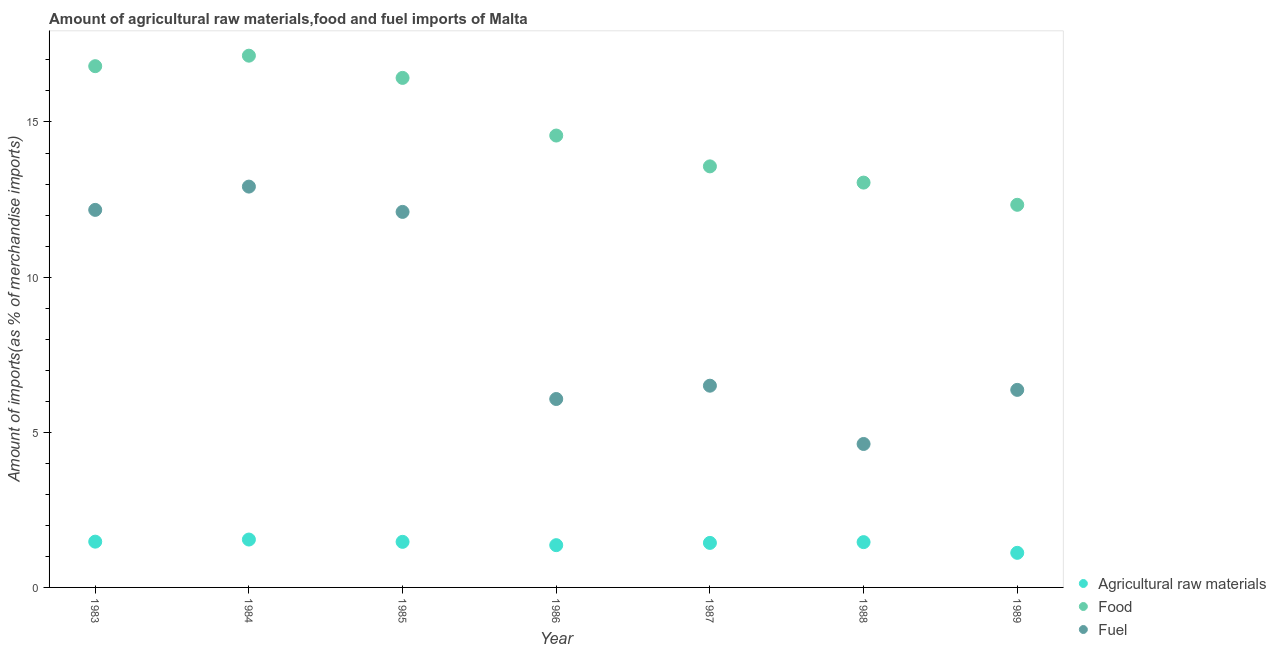How many different coloured dotlines are there?
Give a very brief answer. 3. Is the number of dotlines equal to the number of legend labels?
Provide a succinct answer. Yes. What is the percentage of food imports in 1984?
Your response must be concise. 17.14. Across all years, what is the maximum percentage of food imports?
Ensure brevity in your answer.  17.14. Across all years, what is the minimum percentage of fuel imports?
Your response must be concise. 4.62. In which year was the percentage of food imports maximum?
Keep it short and to the point. 1984. What is the total percentage of fuel imports in the graph?
Your response must be concise. 60.75. What is the difference between the percentage of fuel imports in 1986 and that in 1987?
Your answer should be very brief. -0.43. What is the difference between the percentage of raw materials imports in 1989 and the percentage of fuel imports in 1988?
Offer a terse response. -3.51. What is the average percentage of fuel imports per year?
Provide a succinct answer. 8.68. In the year 1983, what is the difference between the percentage of raw materials imports and percentage of fuel imports?
Make the answer very short. -10.69. In how many years, is the percentage of food imports greater than 15 %?
Provide a succinct answer. 3. What is the ratio of the percentage of food imports in 1985 to that in 1988?
Your response must be concise. 1.26. Is the percentage of food imports in 1984 less than that in 1988?
Provide a succinct answer. No. Is the difference between the percentage of food imports in 1986 and 1987 greater than the difference between the percentage of raw materials imports in 1986 and 1987?
Keep it short and to the point. Yes. What is the difference between the highest and the second highest percentage of raw materials imports?
Ensure brevity in your answer.  0.07. What is the difference between the highest and the lowest percentage of fuel imports?
Offer a very short reply. 8.29. In how many years, is the percentage of fuel imports greater than the average percentage of fuel imports taken over all years?
Your response must be concise. 3. Is it the case that in every year, the sum of the percentage of raw materials imports and percentage of food imports is greater than the percentage of fuel imports?
Offer a very short reply. Yes. Is the percentage of fuel imports strictly greater than the percentage of raw materials imports over the years?
Your response must be concise. Yes. How many years are there in the graph?
Keep it short and to the point. 7. What is the difference between two consecutive major ticks on the Y-axis?
Give a very brief answer. 5. Are the values on the major ticks of Y-axis written in scientific E-notation?
Give a very brief answer. No. Does the graph contain grids?
Your answer should be compact. No. Where does the legend appear in the graph?
Keep it short and to the point. Bottom right. How many legend labels are there?
Your answer should be very brief. 3. How are the legend labels stacked?
Make the answer very short. Vertical. What is the title of the graph?
Provide a short and direct response. Amount of agricultural raw materials,food and fuel imports of Malta. What is the label or title of the X-axis?
Your answer should be compact. Year. What is the label or title of the Y-axis?
Your response must be concise. Amount of imports(as % of merchandise imports). What is the Amount of imports(as % of merchandise imports) of Agricultural raw materials in 1983?
Keep it short and to the point. 1.48. What is the Amount of imports(as % of merchandise imports) of Food in 1983?
Your answer should be compact. 16.8. What is the Amount of imports(as % of merchandise imports) in Fuel in 1983?
Keep it short and to the point. 12.17. What is the Amount of imports(as % of merchandise imports) in Agricultural raw materials in 1984?
Offer a terse response. 1.54. What is the Amount of imports(as % of merchandise imports) of Food in 1984?
Give a very brief answer. 17.14. What is the Amount of imports(as % of merchandise imports) in Fuel in 1984?
Offer a terse response. 12.92. What is the Amount of imports(as % of merchandise imports) of Agricultural raw materials in 1985?
Provide a succinct answer. 1.47. What is the Amount of imports(as % of merchandise imports) in Food in 1985?
Make the answer very short. 16.42. What is the Amount of imports(as % of merchandise imports) of Fuel in 1985?
Your answer should be compact. 12.1. What is the Amount of imports(as % of merchandise imports) of Agricultural raw materials in 1986?
Ensure brevity in your answer.  1.36. What is the Amount of imports(as % of merchandise imports) in Food in 1986?
Offer a terse response. 14.56. What is the Amount of imports(as % of merchandise imports) of Fuel in 1986?
Your answer should be very brief. 6.07. What is the Amount of imports(as % of merchandise imports) of Agricultural raw materials in 1987?
Give a very brief answer. 1.43. What is the Amount of imports(as % of merchandise imports) of Food in 1987?
Offer a terse response. 13.57. What is the Amount of imports(as % of merchandise imports) of Fuel in 1987?
Make the answer very short. 6.5. What is the Amount of imports(as % of merchandise imports) in Agricultural raw materials in 1988?
Offer a very short reply. 1.46. What is the Amount of imports(as % of merchandise imports) in Food in 1988?
Make the answer very short. 13.05. What is the Amount of imports(as % of merchandise imports) of Fuel in 1988?
Provide a succinct answer. 4.62. What is the Amount of imports(as % of merchandise imports) of Agricultural raw materials in 1989?
Offer a terse response. 1.11. What is the Amount of imports(as % of merchandise imports) of Food in 1989?
Make the answer very short. 12.33. What is the Amount of imports(as % of merchandise imports) of Fuel in 1989?
Provide a succinct answer. 6.37. Across all years, what is the maximum Amount of imports(as % of merchandise imports) of Agricultural raw materials?
Make the answer very short. 1.54. Across all years, what is the maximum Amount of imports(as % of merchandise imports) of Food?
Provide a short and direct response. 17.14. Across all years, what is the maximum Amount of imports(as % of merchandise imports) in Fuel?
Make the answer very short. 12.92. Across all years, what is the minimum Amount of imports(as % of merchandise imports) in Agricultural raw materials?
Ensure brevity in your answer.  1.11. Across all years, what is the minimum Amount of imports(as % of merchandise imports) of Food?
Provide a succinct answer. 12.33. Across all years, what is the minimum Amount of imports(as % of merchandise imports) in Fuel?
Provide a succinct answer. 4.62. What is the total Amount of imports(as % of merchandise imports) in Agricultural raw materials in the graph?
Your answer should be very brief. 9.86. What is the total Amount of imports(as % of merchandise imports) in Food in the graph?
Your answer should be compact. 103.87. What is the total Amount of imports(as % of merchandise imports) in Fuel in the graph?
Provide a short and direct response. 60.75. What is the difference between the Amount of imports(as % of merchandise imports) in Agricultural raw materials in 1983 and that in 1984?
Your response must be concise. -0.07. What is the difference between the Amount of imports(as % of merchandise imports) in Food in 1983 and that in 1984?
Provide a succinct answer. -0.34. What is the difference between the Amount of imports(as % of merchandise imports) of Fuel in 1983 and that in 1984?
Give a very brief answer. -0.75. What is the difference between the Amount of imports(as % of merchandise imports) of Agricultural raw materials in 1983 and that in 1985?
Your answer should be compact. 0.01. What is the difference between the Amount of imports(as % of merchandise imports) of Food in 1983 and that in 1985?
Your answer should be very brief. 0.38. What is the difference between the Amount of imports(as % of merchandise imports) in Fuel in 1983 and that in 1985?
Give a very brief answer. 0.07. What is the difference between the Amount of imports(as % of merchandise imports) in Agricultural raw materials in 1983 and that in 1986?
Provide a short and direct response. 0.11. What is the difference between the Amount of imports(as % of merchandise imports) in Food in 1983 and that in 1986?
Your answer should be very brief. 2.24. What is the difference between the Amount of imports(as % of merchandise imports) of Fuel in 1983 and that in 1986?
Ensure brevity in your answer.  6.1. What is the difference between the Amount of imports(as % of merchandise imports) in Agricultural raw materials in 1983 and that in 1987?
Your answer should be compact. 0.04. What is the difference between the Amount of imports(as % of merchandise imports) in Food in 1983 and that in 1987?
Offer a very short reply. 3.23. What is the difference between the Amount of imports(as % of merchandise imports) of Fuel in 1983 and that in 1987?
Your answer should be compact. 5.67. What is the difference between the Amount of imports(as % of merchandise imports) in Agricultural raw materials in 1983 and that in 1988?
Provide a short and direct response. 0.02. What is the difference between the Amount of imports(as % of merchandise imports) of Food in 1983 and that in 1988?
Your response must be concise. 3.75. What is the difference between the Amount of imports(as % of merchandise imports) in Fuel in 1983 and that in 1988?
Ensure brevity in your answer.  7.54. What is the difference between the Amount of imports(as % of merchandise imports) in Agricultural raw materials in 1983 and that in 1989?
Offer a terse response. 0.36. What is the difference between the Amount of imports(as % of merchandise imports) in Food in 1983 and that in 1989?
Offer a terse response. 4.47. What is the difference between the Amount of imports(as % of merchandise imports) of Fuel in 1983 and that in 1989?
Ensure brevity in your answer.  5.8. What is the difference between the Amount of imports(as % of merchandise imports) in Agricultural raw materials in 1984 and that in 1985?
Your response must be concise. 0.07. What is the difference between the Amount of imports(as % of merchandise imports) of Food in 1984 and that in 1985?
Keep it short and to the point. 0.72. What is the difference between the Amount of imports(as % of merchandise imports) in Fuel in 1984 and that in 1985?
Provide a succinct answer. 0.82. What is the difference between the Amount of imports(as % of merchandise imports) of Agricultural raw materials in 1984 and that in 1986?
Give a very brief answer. 0.18. What is the difference between the Amount of imports(as % of merchandise imports) in Food in 1984 and that in 1986?
Keep it short and to the point. 2.57. What is the difference between the Amount of imports(as % of merchandise imports) in Fuel in 1984 and that in 1986?
Offer a very short reply. 6.85. What is the difference between the Amount of imports(as % of merchandise imports) in Agricultural raw materials in 1984 and that in 1987?
Provide a short and direct response. 0.11. What is the difference between the Amount of imports(as % of merchandise imports) in Food in 1984 and that in 1987?
Offer a terse response. 3.57. What is the difference between the Amount of imports(as % of merchandise imports) in Fuel in 1984 and that in 1987?
Make the answer very short. 6.42. What is the difference between the Amount of imports(as % of merchandise imports) of Agricultural raw materials in 1984 and that in 1988?
Your answer should be very brief. 0.08. What is the difference between the Amount of imports(as % of merchandise imports) in Food in 1984 and that in 1988?
Ensure brevity in your answer.  4.09. What is the difference between the Amount of imports(as % of merchandise imports) of Fuel in 1984 and that in 1988?
Provide a succinct answer. 8.29. What is the difference between the Amount of imports(as % of merchandise imports) in Agricultural raw materials in 1984 and that in 1989?
Offer a terse response. 0.43. What is the difference between the Amount of imports(as % of merchandise imports) of Food in 1984 and that in 1989?
Make the answer very short. 4.81. What is the difference between the Amount of imports(as % of merchandise imports) in Fuel in 1984 and that in 1989?
Your response must be concise. 6.55. What is the difference between the Amount of imports(as % of merchandise imports) in Agricultural raw materials in 1985 and that in 1986?
Make the answer very short. 0.11. What is the difference between the Amount of imports(as % of merchandise imports) in Food in 1985 and that in 1986?
Provide a succinct answer. 1.86. What is the difference between the Amount of imports(as % of merchandise imports) in Fuel in 1985 and that in 1986?
Make the answer very short. 6.03. What is the difference between the Amount of imports(as % of merchandise imports) in Agricultural raw materials in 1985 and that in 1987?
Offer a very short reply. 0.03. What is the difference between the Amount of imports(as % of merchandise imports) in Food in 1985 and that in 1987?
Your answer should be compact. 2.85. What is the difference between the Amount of imports(as % of merchandise imports) in Fuel in 1985 and that in 1987?
Offer a terse response. 5.6. What is the difference between the Amount of imports(as % of merchandise imports) in Agricultural raw materials in 1985 and that in 1988?
Offer a terse response. 0.01. What is the difference between the Amount of imports(as % of merchandise imports) in Food in 1985 and that in 1988?
Provide a succinct answer. 3.37. What is the difference between the Amount of imports(as % of merchandise imports) in Fuel in 1985 and that in 1988?
Offer a very short reply. 7.48. What is the difference between the Amount of imports(as % of merchandise imports) in Agricultural raw materials in 1985 and that in 1989?
Provide a succinct answer. 0.35. What is the difference between the Amount of imports(as % of merchandise imports) in Food in 1985 and that in 1989?
Offer a terse response. 4.09. What is the difference between the Amount of imports(as % of merchandise imports) of Fuel in 1985 and that in 1989?
Offer a very short reply. 5.74. What is the difference between the Amount of imports(as % of merchandise imports) of Agricultural raw materials in 1986 and that in 1987?
Make the answer very short. -0.07. What is the difference between the Amount of imports(as % of merchandise imports) of Fuel in 1986 and that in 1987?
Offer a very short reply. -0.43. What is the difference between the Amount of imports(as % of merchandise imports) of Agricultural raw materials in 1986 and that in 1988?
Make the answer very short. -0.1. What is the difference between the Amount of imports(as % of merchandise imports) of Food in 1986 and that in 1988?
Keep it short and to the point. 1.52. What is the difference between the Amount of imports(as % of merchandise imports) in Fuel in 1986 and that in 1988?
Your answer should be very brief. 1.45. What is the difference between the Amount of imports(as % of merchandise imports) in Agricultural raw materials in 1986 and that in 1989?
Provide a short and direct response. 0.25. What is the difference between the Amount of imports(as % of merchandise imports) of Food in 1986 and that in 1989?
Offer a terse response. 2.23. What is the difference between the Amount of imports(as % of merchandise imports) of Fuel in 1986 and that in 1989?
Make the answer very short. -0.29. What is the difference between the Amount of imports(as % of merchandise imports) in Agricultural raw materials in 1987 and that in 1988?
Make the answer very short. -0.02. What is the difference between the Amount of imports(as % of merchandise imports) in Food in 1987 and that in 1988?
Give a very brief answer. 0.52. What is the difference between the Amount of imports(as % of merchandise imports) of Fuel in 1987 and that in 1988?
Ensure brevity in your answer.  1.88. What is the difference between the Amount of imports(as % of merchandise imports) in Agricultural raw materials in 1987 and that in 1989?
Your answer should be compact. 0.32. What is the difference between the Amount of imports(as % of merchandise imports) of Food in 1987 and that in 1989?
Keep it short and to the point. 1.24. What is the difference between the Amount of imports(as % of merchandise imports) in Fuel in 1987 and that in 1989?
Give a very brief answer. 0.13. What is the difference between the Amount of imports(as % of merchandise imports) in Agricultural raw materials in 1988 and that in 1989?
Offer a very short reply. 0.34. What is the difference between the Amount of imports(as % of merchandise imports) of Food in 1988 and that in 1989?
Your answer should be very brief. 0.72. What is the difference between the Amount of imports(as % of merchandise imports) of Fuel in 1988 and that in 1989?
Offer a very short reply. -1.74. What is the difference between the Amount of imports(as % of merchandise imports) in Agricultural raw materials in 1983 and the Amount of imports(as % of merchandise imports) in Food in 1984?
Offer a very short reply. -15.66. What is the difference between the Amount of imports(as % of merchandise imports) of Agricultural raw materials in 1983 and the Amount of imports(as % of merchandise imports) of Fuel in 1984?
Make the answer very short. -11.44. What is the difference between the Amount of imports(as % of merchandise imports) of Food in 1983 and the Amount of imports(as % of merchandise imports) of Fuel in 1984?
Give a very brief answer. 3.88. What is the difference between the Amount of imports(as % of merchandise imports) of Agricultural raw materials in 1983 and the Amount of imports(as % of merchandise imports) of Food in 1985?
Make the answer very short. -14.95. What is the difference between the Amount of imports(as % of merchandise imports) of Agricultural raw materials in 1983 and the Amount of imports(as % of merchandise imports) of Fuel in 1985?
Offer a terse response. -10.63. What is the difference between the Amount of imports(as % of merchandise imports) of Food in 1983 and the Amount of imports(as % of merchandise imports) of Fuel in 1985?
Your response must be concise. 4.7. What is the difference between the Amount of imports(as % of merchandise imports) in Agricultural raw materials in 1983 and the Amount of imports(as % of merchandise imports) in Food in 1986?
Your answer should be very brief. -13.09. What is the difference between the Amount of imports(as % of merchandise imports) of Agricultural raw materials in 1983 and the Amount of imports(as % of merchandise imports) of Fuel in 1986?
Offer a terse response. -4.6. What is the difference between the Amount of imports(as % of merchandise imports) of Food in 1983 and the Amount of imports(as % of merchandise imports) of Fuel in 1986?
Provide a succinct answer. 10.73. What is the difference between the Amount of imports(as % of merchandise imports) of Agricultural raw materials in 1983 and the Amount of imports(as % of merchandise imports) of Food in 1987?
Your answer should be compact. -12.09. What is the difference between the Amount of imports(as % of merchandise imports) in Agricultural raw materials in 1983 and the Amount of imports(as % of merchandise imports) in Fuel in 1987?
Make the answer very short. -5.03. What is the difference between the Amount of imports(as % of merchandise imports) in Food in 1983 and the Amount of imports(as % of merchandise imports) in Fuel in 1987?
Make the answer very short. 10.3. What is the difference between the Amount of imports(as % of merchandise imports) of Agricultural raw materials in 1983 and the Amount of imports(as % of merchandise imports) of Food in 1988?
Make the answer very short. -11.57. What is the difference between the Amount of imports(as % of merchandise imports) in Agricultural raw materials in 1983 and the Amount of imports(as % of merchandise imports) in Fuel in 1988?
Offer a terse response. -3.15. What is the difference between the Amount of imports(as % of merchandise imports) in Food in 1983 and the Amount of imports(as % of merchandise imports) in Fuel in 1988?
Keep it short and to the point. 12.18. What is the difference between the Amount of imports(as % of merchandise imports) of Agricultural raw materials in 1983 and the Amount of imports(as % of merchandise imports) of Food in 1989?
Provide a short and direct response. -10.86. What is the difference between the Amount of imports(as % of merchandise imports) in Agricultural raw materials in 1983 and the Amount of imports(as % of merchandise imports) in Fuel in 1989?
Offer a terse response. -4.89. What is the difference between the Amount of imports(as % of merchandise imports) of Food in 1983 and the Amount of imports(as % of merchandise imports) of Fuel in 1989?
Provide a succinct answer. 10.43. What is the difference between the Amount of imports(as % of merchandise imports) in Agricultural raw materials in 1984 and the Amount of imports(as % of merchandise imports) in Food in 1985?
Provide a succinct answer. -14.88. What is the difference between the Amount of imports(as % of merchandise imports) in Agricultural raw materials in 1984 and the Amount of imports(as % of merchandise imports) in Fuel in 1985?
Your answer should be compact. -10.56. What is the difference between the Amount of imports(as % of merchandise imports) in Food in 1984 and the Amount of imports(as % of merchandise imports) in Fuel in 1985?
Keep it short and to the point. 5.03. What is the difference between the Amount of imports(as % of merchandise imports) of Agricultural raw materials in 1984 and the Amount of imports(as % of merchandise imports) of Food in 1986?
Offer a very short reply. -13.02. What is the difference between the Amount of imports(as % of merchandise imports) of Agricultural raw materials in 1984 and the Amount of imports(as % of merchandise imports) of Fuel in 1986?
Make the answer very short. -4.53. What is the difference between the Amount of imports(as % of merchandise imports) in Food in 1984 and the Amount of imports(as % of merchandise imports) in Fuel in 1986?
Your answer should be compact. 11.06. What is the difference between the Amount of imports(as % of merchandise imports) of Agricultural raw materials in 1984 and the Amount of imports(as % of merchandise imports) of Food in 1987?
Give a very brief answer. -12.03. What is the difference between the Amount of imports(as % of merchandise imports) in Agricultural raw materials in 1984 and the Amount of imports(as % of merchandise imports) in Fuel in 1987?
Keep it short and to the point. -4.96. What is the difference between the Amount of imports(as % of merchandise imports) in Food in 1984 and the Amount of imports(as % of merchandise imports) in Fuel in 1987?
Provide a succinct answer. 10.64. What is the difference between the Amount of imports(as % of merchandise imports) of Agricultural raw materials in 1984 and the Amount of imports(as % of merchandise imports) of Food in 1988?
Your response must be concise. -11.5. What is the difference between the Amount of imports(as % of merchandise imports) of Agricultural raw materials in 1984 and the Amount of imports(as % of merchandise imports) of Fuel in 1988?
Your answer should be very brief. -3.08. What is the difference between the Amount of imports(as % of merchandise imports) of Food in 1984 and the Amount of imports(as % of merchandise imports) of Fuel in 1988?
Provide a short and direct response. 12.51. What is the difference between the Amount of imports(as % of merchandise imports) in Agricultural raw materials in 1984 and the Amount of imports(as % of merchandise imports) in Food in 1989?
Keep it short and to the point. -10.79. What is the difference between the Amount of imports(as % of merchandise imports) in Agricultural raw materials in 1984 and the Amount of imports(as % of merchandise imports) in Fuel in 1989?
Offer a very short reply. -4.82. What is the difference between the Amount of imports(as % of merchandise imports) in Food in 1984 and the Amount of imports(as % of merchandise imports) in Fuel in 1989?
Provide a succinct answer. 10.77. What is the difference between the Amount of imports(as % of merchandise imports) in Agricultural raw materials in 1985 and the Amount of imports(as % of merchandise imports) in Food in 1986?
Your response must be concise. -13.09. What is the difference between the Amount of imports(as % of merchandise imports) of Agricultural raw materials in 1985 and the Amount of imports(as % of merchandise imports) of Fuel in 1986?
Make the answer very short. -4.6. What is the difference between the Amount of imports(as % of merchandise imports) of Food in 1985 and the Amount of imports(as % of merchandise imports) of Fuel in 1986?
Your answer should be compact. 10.35. What is the difference between the Amount of imports(as % of merchandise imports) in Agricultural raw materials in 1985 and the Amount of imports(as % of merchandise imports) in Food in 1987?
Your answer should be compact. -12.1. What is the difference between the Amount of imports(as % of merchandise imports) of Agricultural raw materials in 1985 and the Amount of imports(as % of merchandise imports) of Fuel in 1987?
Offer a terse response. -5.03. What is the difference between the Amount of imports(as % of merchandise imports) of Food in 1985 and the Amount of imports(as % of merchandise imports) of Fuel in 1987?
Ensure brevity in your answer.  9.92. What is the difference between the Amount of imports(as % of merchandise imports) in Agricultural raw materials in 1985 and the Amount of imports(as % of merchandise imports) in Food in 1988?
Your answer should be very brief. -11.58. What is the difference between the Amount of imports(as % of merchandise imports) of Agricultural raw materials in 1985 and the Amount of imports(as % of merchandise imports) of Fuel in 1988?
Provide a succinct answer. -3.15. What is the difference between the Amount of imports(as % of merchandise imports) of Food in 1985 and the Amount of imports(as % of merchandise imports) of Fuel in 1988?
Give a very brief answer. 11.8. What is the difference between the Amount of imports(as % of merchandise imports) of Agricultural raw materials in 1985 and the Amount of imports(as % of merchandise imports) of Food in 1989?
Offer a very short reply. -10.86. What is the difference between the Amount of imports(as % of merchandise imports) in Agricultural raw materials in 1985 and the Amount of imports(as % of merchandise imports) in Fuel in 1989?
Keep it short and to the point. -4.9. What is the difference between the Amount of imports(as % of merchandise imports) of Food in 1985 and the Amount of imports(as % of merchandise imports) of Fuel in 1989?
Provide a succinct answer. 10.05. What is the difference between the Amount of imports(as % of merchandise imports) of Agricultural raw materials in 1986 and the Amount of imports(as % of merchandise imports) of Food in 1987?
Make the answer very short. -12.21. What is the difference between the Amount of imports(as % of merchandise imports) of Agricultural raw materials in 1986 and the Amount of imports(as % of merchandise imports) of Fuel in 1987?
Keep it short and to the point. -5.14. What is the difference between the Amount of imports(as % of merchandise imports) of Food in 1986 and the Amount of imports(as % of merchandise imports) of Fuel in 1987?
Provide a succinct answer. 8.06. What is the difference between the Amount of imports(as % of merchandise imports) of Agricultural raw materials in 1986 and the Amount of imports(as % of merchandise imports) of Food in 1988?
Your answer should be very brief. -11.68. What is the difference between the Amount of imports(as % of merchandise imports) in Agricultural raw materials in 1986 and the Amount of imports(as % of merchandise imports) in Fuel in 1988?
Provide a succinct answer. -3.26. What is the difference between the Amount of imports(as % of merchandise imports) of Food in 1986 and the Amount of imports(as % of merchandise imports) of Fuel in 1988?
Give a very brief answer. 9.94. What is the difference between the Amount of imports(as % of merchandise imports) of Agricultural raw materials in 1986 and the Amount of imports(as % of merchandise imports) of Food in 1989?
Make the answer very short. -10.97. What is the difference between the Amount of imports(as % of merchandise imports) of Agricultural raw materials in 1986 and the Amount of imports(as % of merchandise imports) of Fuel in 1989?
Your response must be concise. -5. What is the difference between the Amount of imports(as % of merchandise imports) of Food in 1986 and the Amount of imports(as % of merchandise imports) of Fuel in 1989?
Your response must be concise. 8.2. What is the difference between the Amount of imports(as % of merchandise imports) in Agricultural raw materials in 1987 and the Amount of imports(as % of merchandise imports) in Food in 1988?
Offer a very short reply. -11.61. What is the difference between the Amount of imports(as % of merchandise imports) of Agricultural raw materials in 1987 and the Amount of imports(as % of merchandise imports) of Fuel in 1988?
Provide a succinct answer. -3.19. What is the difference between the Amount of imports(as % of merchandise imports) of Food in 1987 and the Amount of imports(as % of merchandise imports) of Fuel in 1988?
Your response must be concise. 8.95. What is the difference between the Amount of imports(as % of merchandise imports) in Agricultural raw materials in 1987 and the Amount of imports(as % of merchandise imports) in Food in 1989?
Your answer should be very brief. -10.9. What is the difference between the Amount of imports(as % of merchandise imports) of Agricultural raw materials in 1987 and the Amount of imports(as % of merchandise imports) of Fuel in 1989?
Make the answer very short. -4.93. What is the difference between the Amount of imports(as % of merchandise imports) in Food in 1987 and the Amount of imports(as % of merchandise imports) in Fuel in 1989?
Your answer should be compact. 7.2. What is the difference between the Amount of imports(as % of merchandise imports) in Agricultural raw materials in 1988 and the Amount of imports(as % of merchandise imports) in Food in 1989?
Your response must be concise. -10.87. What is the difference between the Amount of imports(as % of merchandise imports) of Agricultural raw materials in 1988 and the Amount of imports(as % of merchandise imports) of Fuel in 1989?
Offer a terse response. -4.91. What is the difference between the Amount of imports(as % of merchandise imports) in Food in 1988 and the Amount of imports(as % of merchandise imports) in Fuel in 1989?
Give a very brief answer. 6.68. What is the average Amount of imports(as % of merchandise imports) of Agricultural raw materials per year?
Your answer should be compact. 1.41. What is the average Amount of imports(as % of merchandise imports) of Food per year?
Ensure brevity in your answer.  14.84. What is the average Amount of imports(as % of merchandise imports) in Fuel per year?
Provide a succinct answer. 8.68. In the year 1983, what is the difference between the Amount of imports(as % of merchandise imports) of Agricultural raw materials and Amount of imports(as % of merchandise imports) of Food?
Keep it short and to the point. -15.32. In the year 1983, what is the difference between the Amount of imports(as % of merchandise imports) of Agricultural raw materials and Amount of imports(as % of merchandise imports) of Fuel?
Make the answer very short. -10.69. In the year 1983, what is the difference between the Amount of imports(as % of merchandise imports) of Food and Amount of imports(as % of merchandise imports) of Fuel?
Make the answer very short. 4.63. In the year 1984, what is the difference between the Amount of imports(as % of merchandise imports) of Agricultural raw materials and Amount of imports(as % of merchandise imports) of Food?
Keep it short and to the point. -15.59. In the year 1984, what is the difference between the Amount of imports(as % of merchandise imports) in Agricultural raw materials and Amount of imports(as % of merchandise imports) in Fuel?
Provide a short and direct response. -11.37. In the year 1984, what is the difference between the Amount of imports(as % of merchandise imports) of Food and Amount of imports(as % of merchandise imports) of Fuel?
Ensure brevity in your answer.  4.22. In the year 1985, what is the difference between the Amount of imports(as % of merchandise imports) in Agricultural raw materials and Amount of imports(as % of merchandise imports) in Food?
Offer a terse response. -14.95. In the year 1985, what is the difference between the Amount of imports(as % of merchandise imports) in Agricultural raw materials and Amount of imports(as % of merchandise imports) in Fuel?
Offer a terse response. -10.63. In the year 1985, what is the difference between the Amount of imports(as % of merchandise imports) in Food and Amount of imports(as % of merchandise imports) in Fuel?
Ensure brevity in your answer.  4.32. In the year 1986, what is the difference between the Amount of imports(as % of merchandise imports) in Agricultural raw materials and Amount of imports(as % of merchandise imports) in Food?
Your response must be concise. -13.2. In the year 1986, what is the difference between the Amount of imports(as % of merchandise imports) of Agricultural raw materials and Amount of imports(as % of merchandise imports) of Fuel?
Give a very brief answer. -4.71. In the year 1986, what is the difference between the Amount of imports(as % of merchandise imports) in Food and Amount of imports(as % of merchandise imports) in Fuel?
Provide a short and direct response. 8.49. In the year 1987, what is the difference between the Amount of imports(as % of merchandise imports) in Agricultural raw materials and Amount of imports(as % of merchandise imports) in Food?
Your response must be concise. -12.13. In the year 1987, what is the difference between the Amount of imports(as % of merchandise imports) of Agricultural raw materials and Amount of imports(as % of merchandise imports) of Fuel?
Give a very brief answer. -5.07. In the year 1987, what is the difference between the Amount of imports(as % of merchandise imports) in Food and Amount of imports(as % of merchandise imports) in Fuel?
Your answer should be very brief. 7.07. In the year 1988, what is the difference between the Amount of imports(as % of merchandise imports) in Agricultural raw materials and Amount of imports(as % of merchandise imports) in Food?
Give a very brief answer. -11.59. In the year 1988, what is the difference between the Amount of imports(as % of merchandise imports) in Agricultural raw materials and Amount of imports(as % of merchandise imports) in Fuel?
Provide a short and direct response. -3.16. In the year 1988, what is the difference between the Amount of imports(as % of merchandise imports) of Food and Amount of imports(as % of merchandise imports) of Fuel?
Your answer should be compact. 8.42. In the year 1989, what is the difference between the Amount of imports(as % of merchandise imports) in Agricultural raw materials and Amount of imports(as % of merchandise imports) in Food?
Provide a short and direct response. -11.22. In the year 1989, what is the difference between the Amount of imports(as % of merchandise imports) of Agricultural raw materials and Amount of imports(as % of merchandise imports) of Fuel?
Give a very brief answer. -5.25. In the year 1989, what is the difference between the Amount of imports(as % of merchandise imports) in Food and Amount of imports(as % of merchandise imports) in Fuel?
Make the answer very short. 5.96. What is the ratio of the Amount of imports(as % of merchandise imports) in Agricultural raw materials in 1983 to that in 1984?
Provide a succinct answer. 0.96. What is the ratio of the Amount of imports(as % of merchandise imports) in Food in 1983 to that in 1984?
Provide a short and direct response. 0.98. What is the ratio of the Amount of imports(as % of merchandise imports) in Fuel in 1983 to that in 1984?
Make the answer very short. 0.94. What is the ratio of the Amount of imports(as % of merchandise imports) of Food in 1983 to that in 1985?
Keep it short and to the point. 1.02. What is the ratio of the Amount of imports(as % of merchandise imports) of Fuel in 1983 to that in 1985?
Keep it short and to the point. 1.01. What is the ratio of the Amount of imports(as % of merchandise imports) in Agricultural raw materials in 1983 to that in 1986?
Ensure brevity in your answer.  1.08. What is the ratio of the Amount of imports(as % of merchandise imports) in Food in 1983 to that in 1986?
Provide a succinct answer. 1.15. What is the ratio of the Amount of imports(as % of merchandise imports) in Fuel in 1983 to that in 1986?
Offer a very short reply. 2. What is the ratio of the Amount of imports(as % of merchandise imports) in Agricultural raw materials in 1983 to that in 1987?
Give a very brief answer. 1.03. What is the ratio of the Amount of imports(as % of merchandise imports) in Food in 1983 to that in 1987?
Offer a terse response. 1.24. What is the ratio of the Amount of imports(as % of merchandise imports) of Fuel in 1983 to that in 1987?
Give a very brief answer. 1.87. What is the ratio of the Amount of imports(as % of merchandise imports) in Agricultural raw materials in 1983 to that in 1988?
Offer a very short reply. 1.01. What is the ratio of the Amount of imports(as % of merchandise imports) in Food in 1983 to that in 1988?
Provide a short and direct response. 1.29. What is the ratio of the Amount of imports(as % of merchandise imports) of Fuel in 1983 to that in 1988?
Keep it short and to the point. 2.63. What is the ratio of the Amount of imports(as % of merchandise imports) in Agricultural raw materials in 1983 to that in 1989?
Provide a short and direct response. 1.32. What is the ratio of the Amount of imports(as % of merchandise imports) in Food in 1983 to that in 1989?
Provide a succinct answer. 1.36. What is the ratio of the Amount of imports(as % of merchandise imports) of Fuel in 1983 to that in 1989?
Give a very brief answer. 1.91. What is the ratio of the Amount of imports(as % of merchandise imports) of Agricultural raw materials in 1984 to that in 1985?
Give a very brief answer. 1.05. What is the ratio of the Amount of imports(as % of merchandise imports) in Food in 1984 to that in 1985?
Provide a succinct answer. 1.04. What is the ratio of the Amount of imports(as % of merchandise imports) in Fuel in 1984 to that in 1985?
Your response must be concise. 1.07. What is the ratio of the Amount of imports(as % of merchandise imports) of Agricultural raw materials in 1984 to that in 1986?
Offer a terse response. 1.13. What is the ratio of the Amount of imports(as % of merchandise imports) in Food in 1984 to that in 1986?
Your answer should be very brief. 1.18. What is the ratio of the Amount of imports(as % of merchandise imports) in Fuel in 1984 to that in 1986?
Provide a succinct answer. 2.13. What is the ratio of the Amount of imports(as % of merchandise imports) of Agricultural raw materials in 1984 to that in 1987?
Your response must be concise. 1.08. What is the ratio of the Amount of imports(as % of merchandise imports) in Food in 1984 to that in 1987?
Keep it short and to the point. 1.26. What is the ratio of the Amount of imports(as % of merchandise imports) in Fuel in 1984 to that in 1987?
Give a very brief answer. 1.99. What is the ratio of the Amount of imports(as % of merchandise imports) of Agricultural raw materials in 1984 to that in 1988?
Offer a very short reply. 1.06. What is the ratio of the Amount of imports(as % of merchandise imports) in Food in 1984 to that in 1988?
Offer a terse response. 1.31. What is the ratio of the Amount of imports(as % of merchandise imports) of Fuel in 1984 to that in 1988?
Make the answer very short. 2.79. What is the ratio of the Amount of imports(as % of merchandise imports) in Agricultural raw materials in 1984 to that in 1989?
Provide a short and direct response. 1.38. What is the ratio of the Amount of imports(as % of merchandise imports) in Food in 1984 to that in 1989?
Your answer should be very brief. 1.39. What is the ratio of the Amount of imports(as % of merchandise imports) of Fuel in 1984 to that in 1989?
Your answer should be very brief. 2.03. What is the ratio of the Amount of imports(as % of merchandise imports) of Agricultural raw materials in 1985 to that in 1986?
Ensure brevity in your answer.  1.08. What is the ratio of the Amount of imports(as % of merchandise imports) of Food in 1985 to that in 1986?
Ensure brevity in your answer.  1.13. What is the ratio of the Amount of imports(as % of merchandise imports) of Fuel in 1985 to that in 1986?
Keep it short and to the point. 1.99. What is the ratio of the Amount of imports(as % of merchandise imports) in Agricultural raw materials in 1985 to that in 1987?
Your answer should be compact. 1.02. What is the ratio of the Amount of imports(as % of merchandise imports) in Food in 1985 to that in 1987?
Your answer should be compact. 1.21. What is the ratio of the Amount of imports(as % of merchandise imports) of Fuel in 1985 to that in 1987?
Ensure brevity in your answer.  1.86. What is the ratio of the Amount of imports(as % of merchandise imports) in Agricultural raw materials in 1985 to that in 1988?
Your answer should be compact. 1.01. What is the ratio of the Amount of imports(as % of merchandise imports) of Food in 1985 to that in 1988?
Your answer should be very brief. 1.26. What is the ratio of the Amount of imports(as % of merchandise imports) in Fuel in 1985 to that in 1988?
Your response must be concise. 2.62. What is the ratio of the Amount of imports(as % of merchandise imports) in Agricultural raw materials in 1985 to that in 1989?
Your answer should be compact. 1.32. What is the ratio of the Amount of imports(as % of merchandise imports) in Food in 1985 to that in 1989?
Offer a very short reply. 1.33. What is the ratio of the Amount of imports(as % of merchandise imports) of Fuel in 1985 to that in 1989?
Keep it short and to the point. 1.9. What is the ratio of the Amount of imports(as % of merchandise imports) of Agricultural raw materials in 1986 to that in 1987?
Your answer should be very brief. 0.95. What is the ratio of the Amount of imports(as % of merchandise imports) of Food in 1986 to that in 1987?
Provide a short and direct response. 1.07. What is the ratio of the Amount of imports(as % of merchandise imports) in Fuel in 1986 to that in 1987?
Keep it short and to the point. 0.93. What is the ratio of the Amount of imports(as % of merchandise imports) of Agricultural raw materials in 1986 to that in 1988?
Offer a very short reply. 0.93. What is the ratio of the Amount of imports(as % of merchandise imports) in Food in 1986 to that in 1988?
Your answer should be compact. 1.12. What is the ratio of the Amount of imports(as % of merchandise imports) in Fuel in 1986 to that in 1988?
Provide a succinct answer. 1.31. What is the ratio of the Amount of imports(as % of merchandise imports) of Agricultural raw materials in 1986 to that in 1989?
Your answer should be compact. 1.22. What is the ratio of the Amount of imports(as % of merchandise imports) of Food in 1986 to that in 1989?
Keep it short and to the point. 1.18. What is the ratio of the Amount of imports(as % of merchandise imports) of Fuel in 1986 to that in 1989?
Offer a terse response. 0.95. What is the ratio of the Amount of imports(as % of merchandise imports) in Agricultural raw materials in 1987 to that in 1988?
Your answer should be compact. 0.98. What is the ratio of the Amount of imports(as % of merchandise imports) of Food in 1987 to that in 1988?
Make the answer very short. 1.04. What is the ratio of the Amount of imports(as % of merchandise imports) in Fuel in 1987 to that in 1988?
Your answer should be very brief. 1.41. What is the ratio of the Amount of imports(as % of merchandise imports) of Agricultural raw materials in 1987 to that in 1989?
Offer a very short reply. 1.29. What is the ratio of the Amount of imports(as % of merchandise imports) of Food in 1987 to that in 1989?
Your answer should be compact. 1.1. What is the ratio of the Amount of imports(as % of merchandise imports) of Fuel in 1987 to that in 1989?
Keep it short and to the point. 1.02. What is the ratio of the Amount of imports(as % of merchandise imports) in Agricultural raw materials in 1988 to that in 1989?
Provide a short and direct response. 1.31. What is the ratio of the Amount of imports(as % of merchandise imports) in Food in 1988 to that in 1989?
Provide a succinct answer. 1.06. What is the ratio of the Amount of imports(as % of merchandise imports) in Fuel in 1988 to that in 1989?
Make the answer very short. 0.73. What is the difference between the highest and the second highest Amount of imports(as % of merchandise imports) of Agricultural raw materials?
Give a very brief answer. 0.07. What is the difference between the highest and the second highest Amount of imports(as % of merchandise imports) of Food?
Give a very brief answer. 0.34. What is the difference between the highest and the second highest Amount of imports(as % of merchandise imports) in Fuel?
Offer a terse response. 0.75. What is the difference between the highest and the lowest Amount of imports(as % of merchandise imports) in Agricultural raw materials?
Provide a short and direct response. 0.43. What is the difference between the highest and the lowest Amount of imports(as % of merchandise imports) in Food?
Offer a very short reply. 4.81. What is the difference between the highest and the lowest Amount of imports(as % of merchandise imports) of Fuel?
Keep it short and to the point. 8.29. 